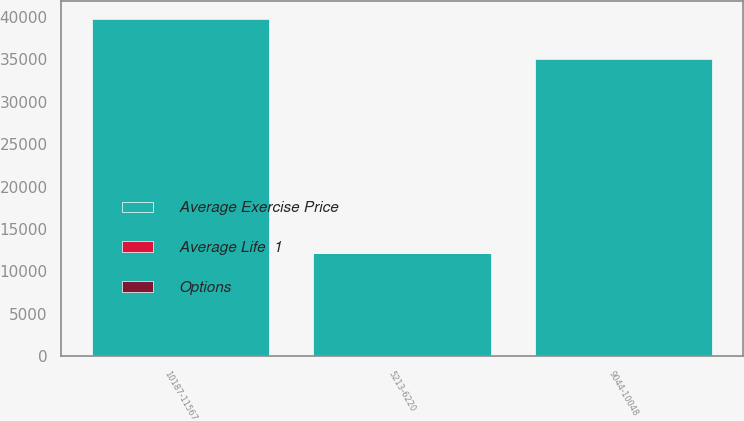<chart> <loc_0><loc_0><loc_500><loc_500><stacked_bar_chart><ecel><fcel>5213-6220<fcel>9044-10048<fcel>10187-11567<nl><fcel>Average Exercise Price<fcel>12148<fcel>35035<fcel>39759<nl><fcel>Options<fcel>1.7<fcel>6.6<fcel>8.6<nl><fcel>Average Life  1<fcel>60.37<fcel>95.48<fcel>108.35<nl></chart> 